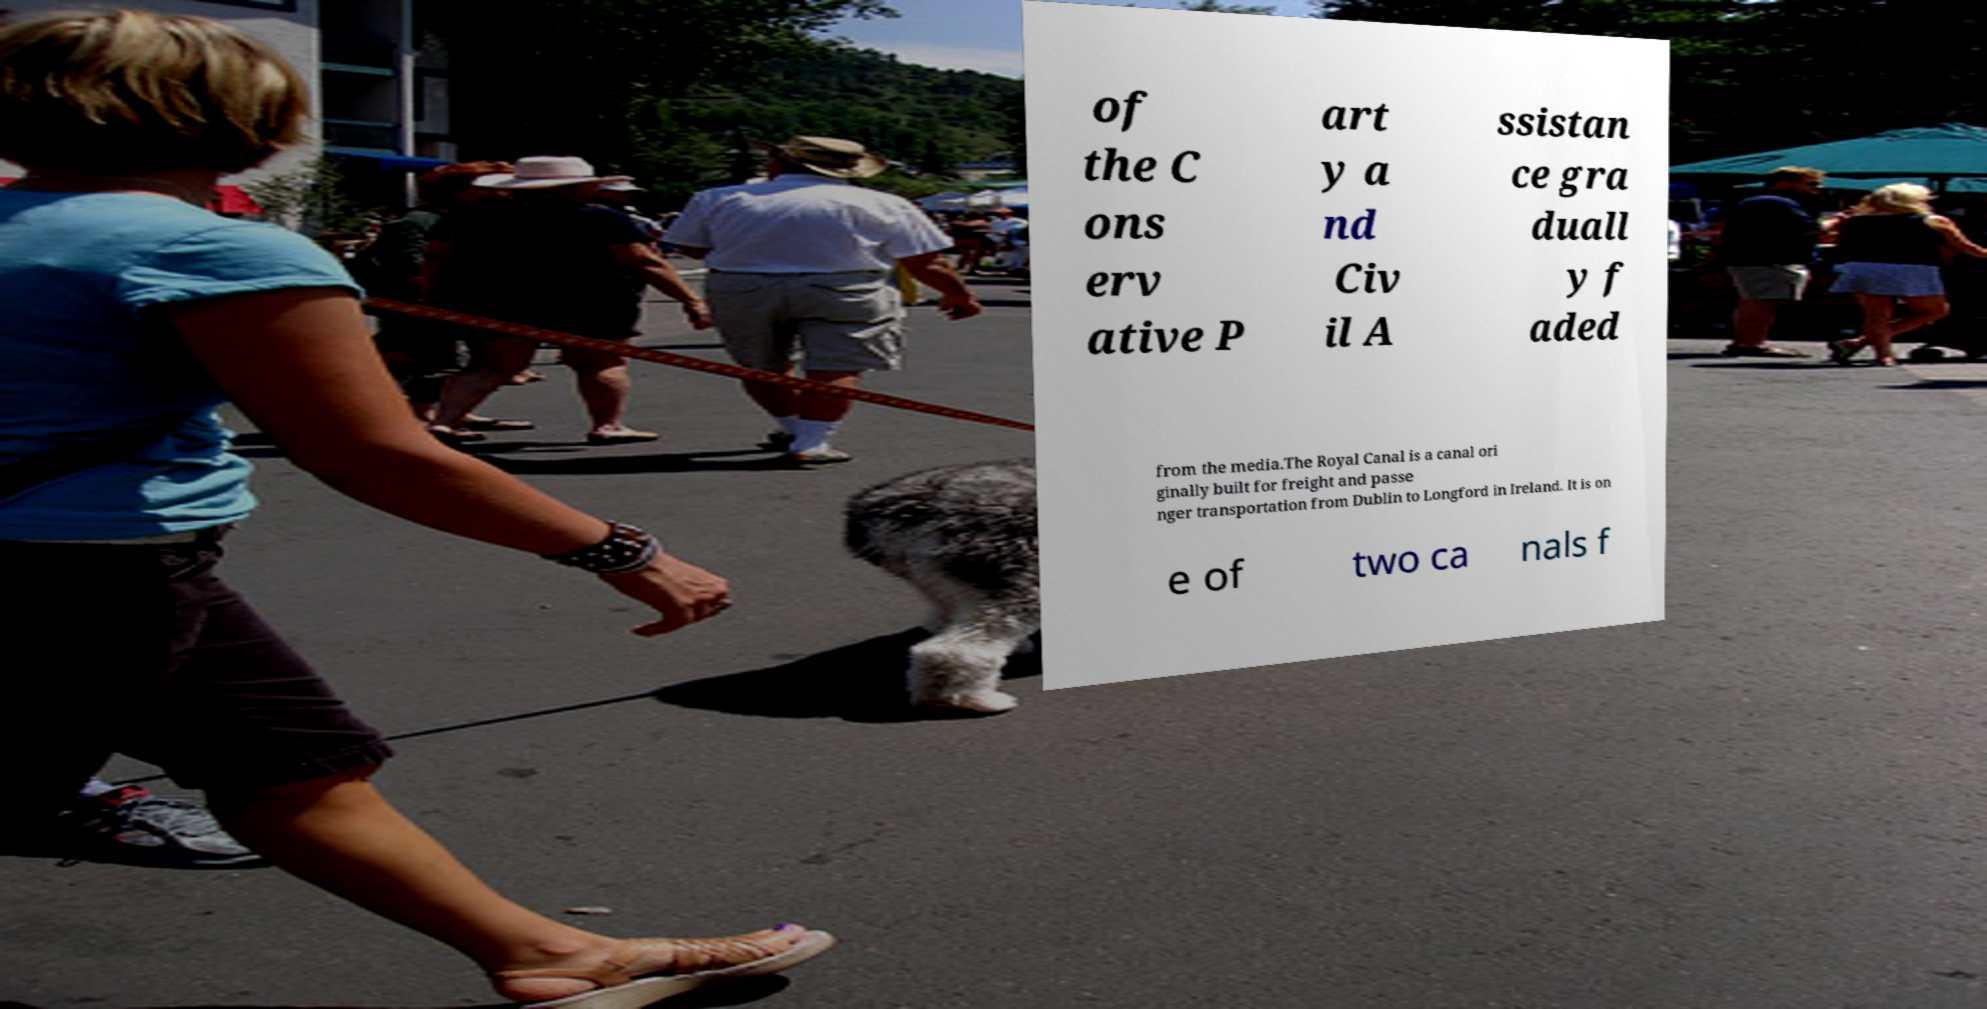Could you extract and type out the text from this image? of the C ons erv ative P art y a nd Civ il A ssistan ce gra duall y f aded from the media.The Royal Canal is a canal ori ginally built for freight and passe nger transportation from Dublin to Longford in Ireland. It is on e of two ca nals f 